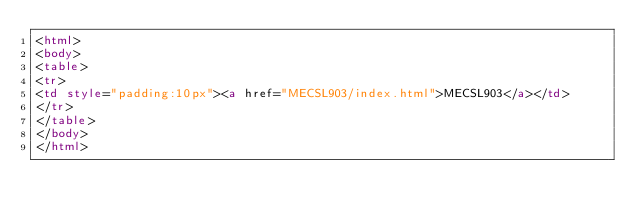<code> <loc_0><loc_0><loc_500><loc_500><_HTML_><html>
<body>
<table>
<tr>
<td style="padding:10px"><a href="MECSL903/index.html">MECSL903</a></td>
</tr>
</table>
</body>
</html>
</code> 